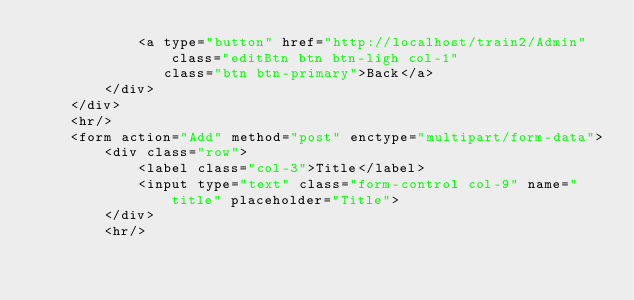Convert code to text. <code><loc_0><loc_0><loc_500><loc_500><_PHP_>            <a type="button" href="http://localhost/train2/Admin" class="editBtn btn btn-ligh col-1"
               class="btn btn-primary">Back</a>
        </div>
    </div>
    <hr/>
    <form action="Add" method="post" enctype="multipart/form-data">
        <div class="row">
            <label class="col-3">Title</label>
            <input type="text" class="form-control col-9" name="title" placeholder="Title">
        </div>
        <hr/></code> 